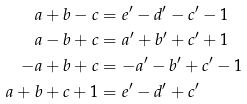Convert formula to latex. <formula><loc_0><loc_0><loc_500><loc_500>a + b - c & = e ^ { \prime } - d ^ { \prime } - c ^ { \prime } - 1 \\ a - b + c & = a ^ { \prime } + b ^ { \prime } + c ^ { \prime } + 1 \\ - a + b + c & = - a ^ { \prime } - b ^ { \prime } + c ^ { \prime } - 1 \\ a + b + c + 1 & = e ^ { \prime } - d ^ { \prime } + c ^ { \prime }</formula> 